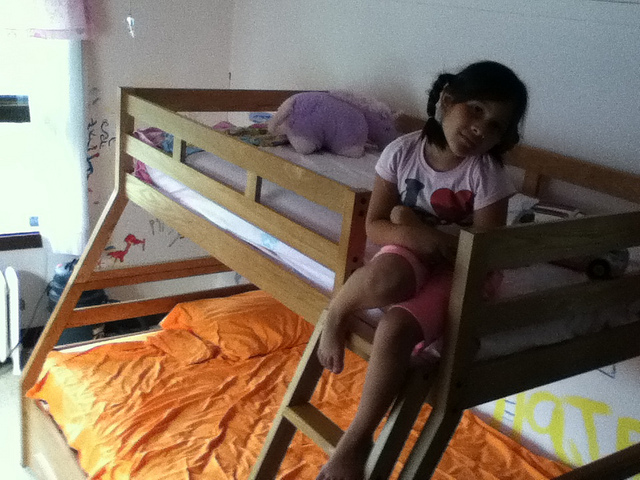<image>What is written on the girl's shirt? I am not sure what is written on the girl's shirt. It could be 'love', 'i heart', 'i 3', or 'i love'. What is written on the girl's shirt? I don't know what is written on the girl's shirt. It can be seen words like 'nothing', 'love', 'i heart', 'i 3', 'i', or 'i love'. 